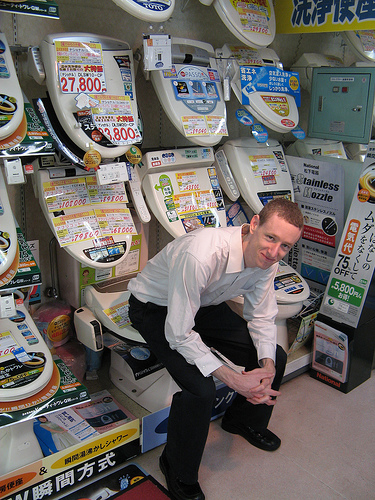What kind of clothing is black? The pants worn by the boy are black, providing a sharp contrast to his light-colored dress shirt. 